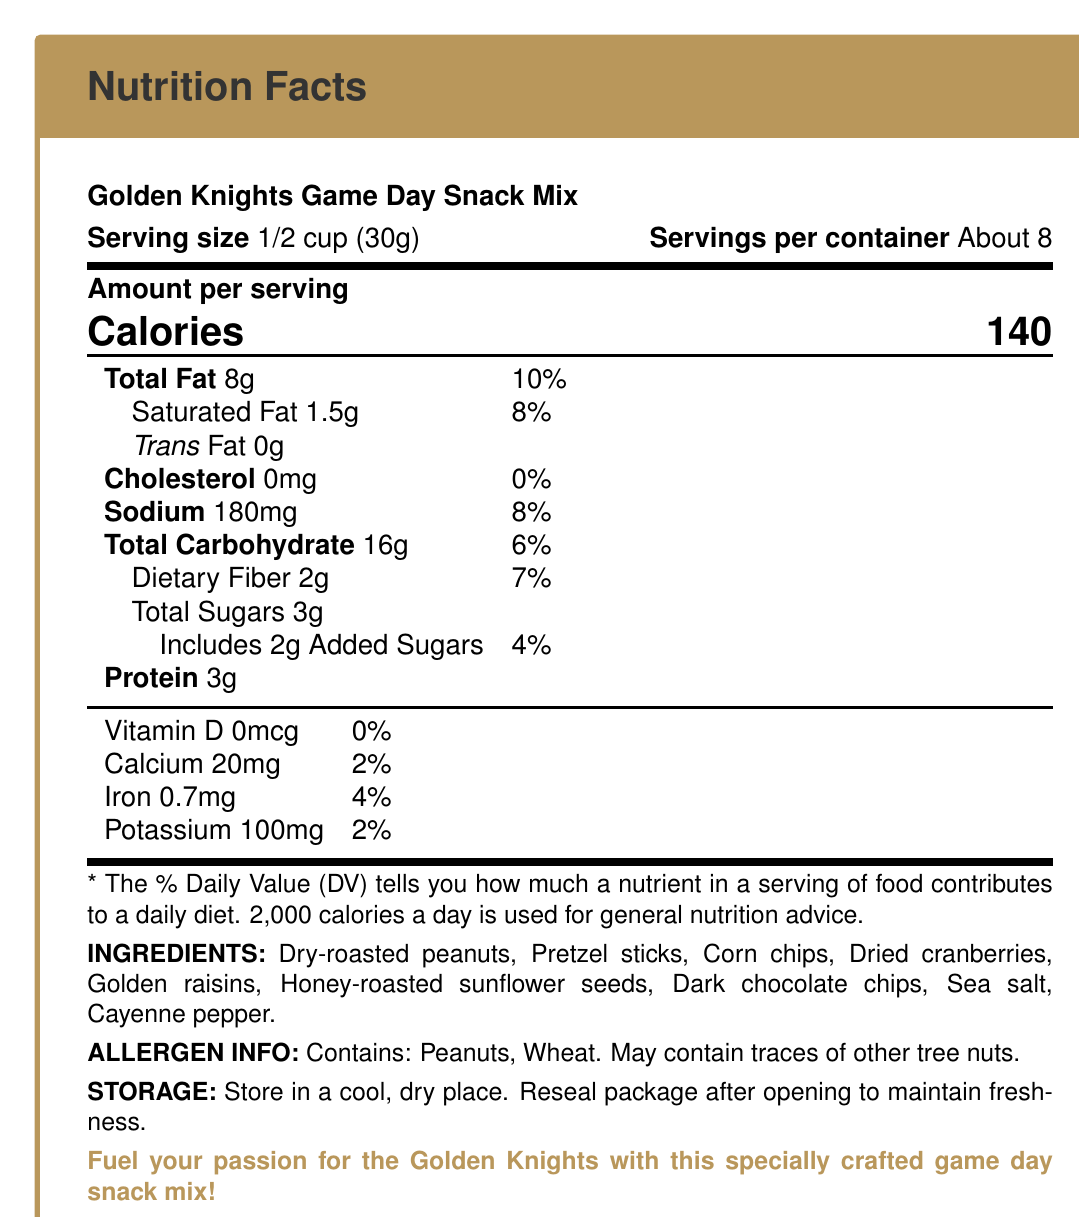what is the serving size for the Golden Knights Game Day Snack Mix? It is stated under the "Serving size" section of the document.
Answer: 1/2 cup (30g) how many calories are in one serving of the snack mix? This information is prominently displayed under "Amount per serving" with a label indicating "Calories."
Answer: 140 calories what percentage of the daily value of total fat does one serving contain? This is mentioned next to the total fat content (8g).
Answer: 10% what are the main ingredients in the snack mix? These are listed under the "INGREDIENTS" section.
Answer: Dry-roasted peanuts, Pretzel sticks, Corn chips, Dried cranberries, Golden raisins, Honey-roasted sunflower seeds, Dark chocolate chips, Sea salt, Cayenne pepper what allergens are indicated in the snack mix? The allergen information is specifically listed under "ALLERGEN INFO."
Answer: Peanuts, Wheat does the snack mix contain any trans fat? It is indicated that there are 0g of trans fat.
Answer: No what percentage of the daily value of sodium does one serving contain? A. 2% B. 4% C. 6% D. 8% The percentage daily value (%DV) for sodium is listed as 8% for 180mg.
Answer: D. 8% how much protein is in one serving of the snack mix? A. 3g B. 4g C. 5g D. 6g It is mentioned under the section with nutritional information.
Answer: A. 3g does the snack mix provide any Vitamin D? The document states that the snack mix contains 0mcg of Vitamin D, which is 0% of the daily value.
Answer: No what flavors are inspired by the Vegas Golden Knights? These flavors are listed as "vegas_inspired_flavors" in the document.
Answer: Golden raisins, Dark chocolate chips, Cayenne pepper, Sea salt where should the snack mix be stored to maintain freshness? This information is mentioned under the "STORAGE" section.
Answer: In a cool, dry place; reseal the package after opening describe the main idea of the document. The document provides all necessary information for consumers to understand the nutritional content and allergen details of the snack mix, along with special features inspired by the Vegas Golden Knights.
Answer: The document is a nutrition facts label for the Golden Knights Game Day Snack Mix, detailing serving size, nutritional content per serving, ingredients, allergen information, storage instructions, and the Vegas-inspired flavors. how much calcium does one serving of the snack mix provide? This is listed under the nutrient breakdown stating "Calcium 20mg."
Answer: 20mg is cayenne pepper one of the ingredients for the snack mix? Cayenne pepper is included in the list of ingredients.
Answer: Yes can the exact ingredient composition be determined? The document lists the ingredients but does not specify the exact proportion of each ingredient.
Answer: Not enough information 